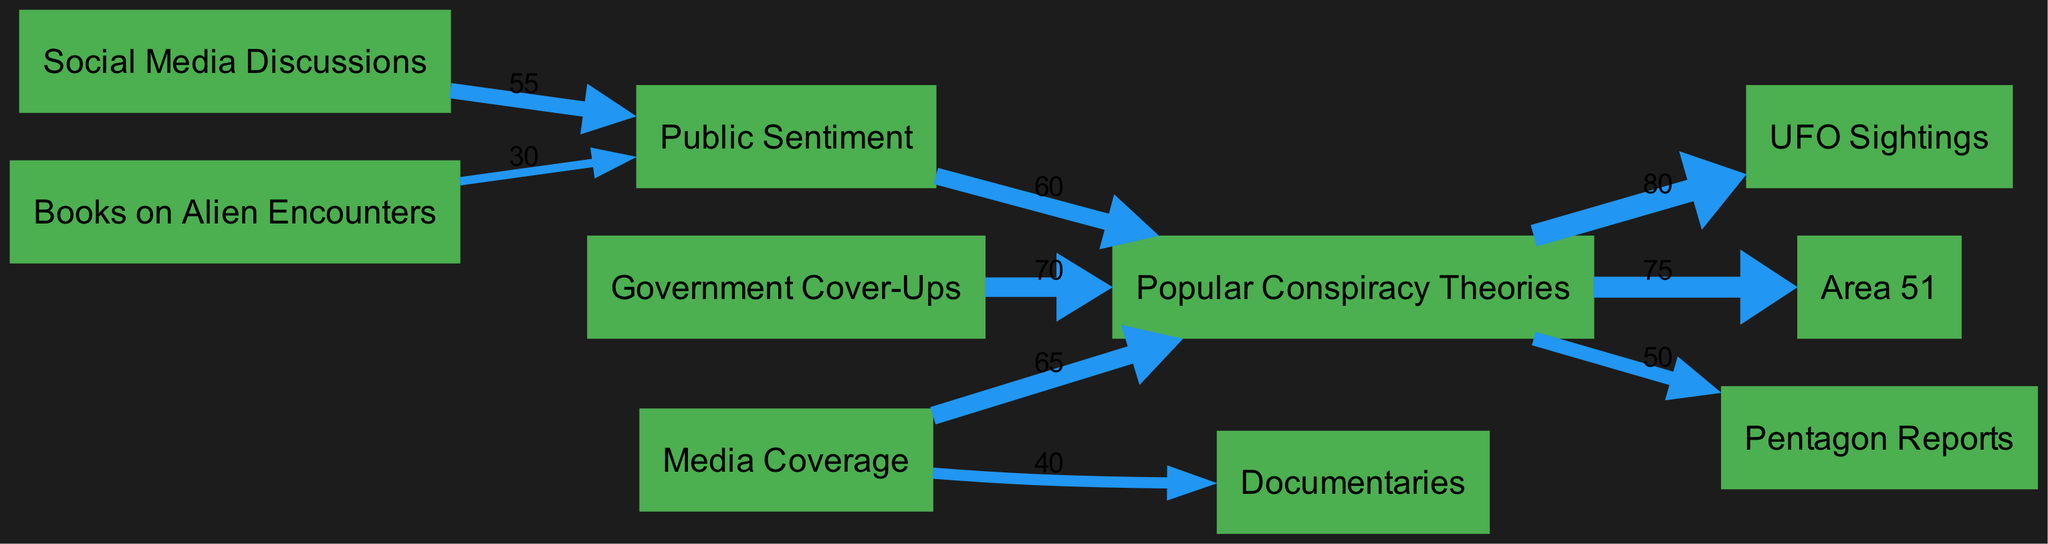What is the total value of the connection from Government Cover-Ups to Popular Conspiracy Theories? The diagram shows the link between the node "Government Cover-Ups" and "Popular Conspiracy Theories" with a value of 70. This value represents the strength or influence of the Government Cover-Ups on the popularity of conspiracy theories.
Answer: 70 How many nodes are present in the diagram? The diagram lists a total of 10 unique nodes that represent different aspects of conspiracy theories about alien life, which include entities like Government Cover-Ups, Media Coverage, and UFO Sightings. Counting each distinct node gives us 10.
Answer: 10 What is the value indicating the connection from Media Coverage to Documentaries? The edge between the nodes "Media Coverage" and "Documentaries" displays a value of 40 in the diagram. This indicates the influence of media coverage on the production or popularity of documentaries related to conspiracy theories.
Answer: 40 Which conspiracy theory has the strongest connection to UFO Sightings? The diagram shows that "Popular Conspiracy Theories" has the strongest connection to "UFO Sightings" with a value of 80, indicating that these theories heavily influence perceptions and reports of UFO Sightings.
Answer: 80 What is the flow value from Social Media Discussions to Public Sentiment? The link from "Social Media Discussions" to "Public Sentiment" has a flow value of 55 shown in the diagram, which illustrates how discussions on social media shape public sentiment regarding conspiracy theories about aliens.
Answer: 55 Which node contributes to Public Sentiment the least, according to the diagram? Upon examining the connections to "Public Sentiment," the least contributing node is "Books on Alien Encounters," with a value of 30. This shows the lower impact of books compared to other sources on shaping public opinions.
Answer: Books on Alien Encounters How does the connection from Popular Conspiracy Theories to Area 51 compare to that of Pentagon Reports? The diagram shows a connection value of 75 from "Popular Conspiracy Theories" to "Area 51" and a value of 50 to "Pentagon Reports." Comparing these values indicates that Area 51 is more strongly associated with popular conspiracy theories than Pentagon Reports are.
Answer: Area 51 What is the total connection value to Popular Conspiracy Theories from all sources combined? To find the total connection to "Popular Conspiracy Theories," sum the values from its inbound links: 70 (Government Cover-Ups) + 65 (Media Coverage) + 60 (Public Sentiment) = 195. This total represents the collective influence of these sources on the popularity of conspiracy theories.
Answer: 195 Which influence contributes most heavily to Popular Conspiracy Theories? The strongest influence on "Popular Conspiracy Theories" is from "Government Cover-Ups" with a value of 70, indicating that this source is the most impactful in generating popularity among these conspiracy theories.
Answer: Government Cover-Ups 